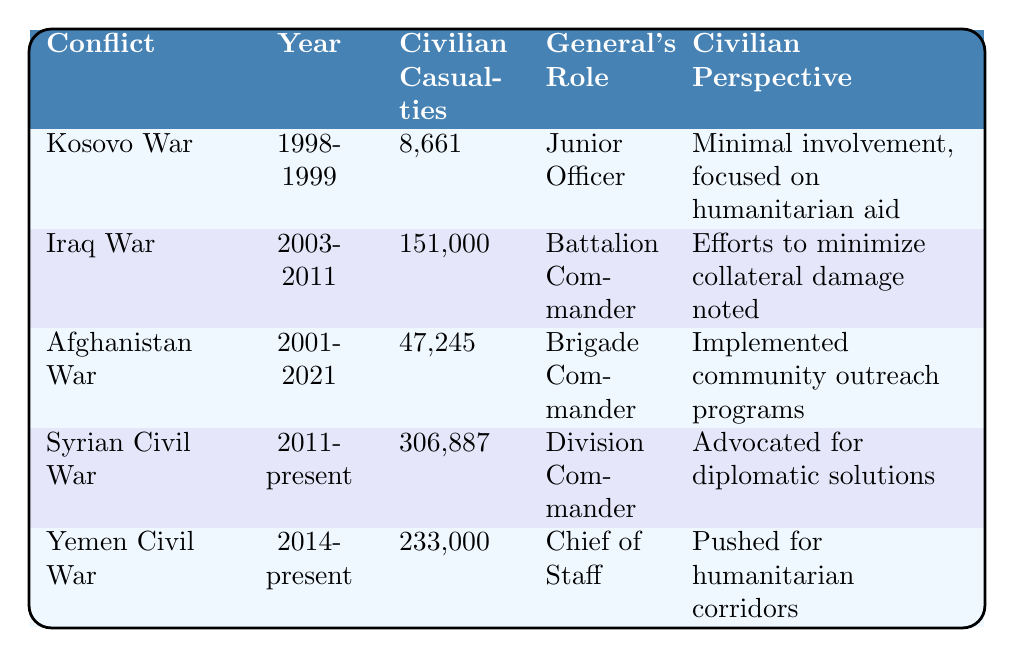What was the civilian casualty count in the Syrian Civil War? The table shows that the civilian casualties in the Syrian Civil War are listed as 306,887.
Answer: 306,887 Who was the general during the Iraq War? The table indicates that the general's role during the Iraq War was Battalion Commander.
Answer: Battalion Commander Which conflict had the highest civilian casualties? By comparing the numbers in the "Civilian Casualties" column, the Syrian Civil War with 306,887 casualties is the highest.
Answer: Syrian Civil War What was the general's role in the Kosovo War? The table specifies that the general's role during the Kosovo War was a Junior Officer.
Answer: Junior Officer How many civilian casualties were there in total for the Iraq and Afghanistan Wars? Adding the civilian casualties: 151,000 (Iraq) + 47,245 (Afghanistan) = 198,245.
Answer: 198,245 Did the general push for humanitarian corridors in the Yemen Civil War? The "Civilian Perspective" column states that the general pushed for humanitarian corridors during the Yemen Civil War, which confirms the fact.
Answer: Yes What was the average number of civilian casualties across all conflicts? To find the average, sum the casualties: 8,661 + 151,000 + 47,245 + 306,887 + 233,000 = 746,793. There are 5 conflicts, so the average is 746,793/5 = 149,358.6.
Answer: 149,358.6 Is it true that the general focused on humanitarian aid during the Kosovo War? The table notes that during the Kosovo War, the general had minimal involvement and focused on humanitarian aid, confirming the fact.
Answer: Yes What roles did the general have from the Kosovo War to the Yemen Civil War? By reading the table, the roles listed are: Junior Officer (Kosovo War), Battalion Commander (Iraq War), Brigade Commander (Afghanistan War), Division Commander (Syrian Civil War), Chief of Staff (Yemen Civil War).
Answer: Junior Officer, Battalion Commander, Brigade Commander, Division Commander, Chief of Staff How many more civilian casualties were there in the Yemen Civil War compared to the Kosovo War? Subtracting the casualties: 233,000 (Yemen) - 8,661 (Kosovo) = 224,339.
Answer: 224,339 